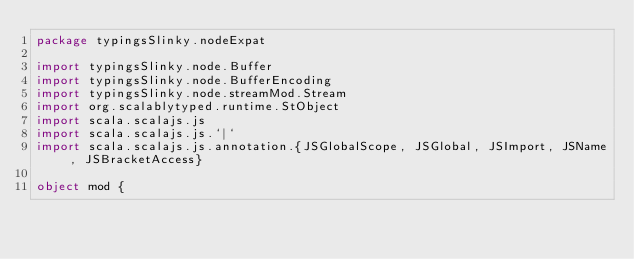<code> <loc_0><loc_0><loc_500><loc_500><_Scala_>package typingsSlinky.nodeExpat

import typingsSlinky.node.Buffer
import typingsSlinky.node.BufferEncoding
import typingsSlinky.node.streamMod.Stream
import org.scalablytyped.runtime.StObject
import scala.scalajs.js
import scala.scalajs.js.`|`
import scala.scalajs.js.annotation.{JSGlobalScope, JSGlobal, JSImport, JSName, JSBracketAccess}

object mod {
  </code> 